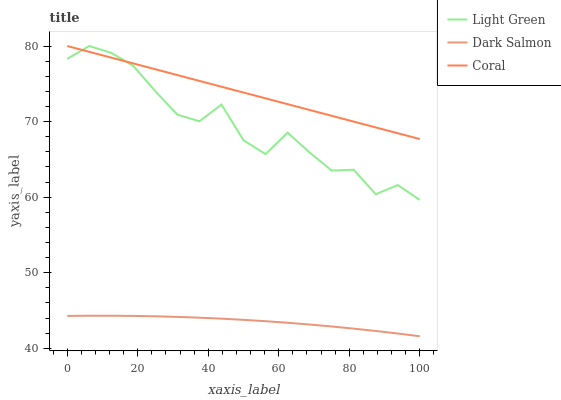Does Dark Salmon have the minimum area under the curve?
Answer yes or no. Yes. Does Coral have the maximum area under the curve?
Answer yes or no. Yes. Does Light Green have the minimum area under the curve?
Answer yes or no. No. Does Light Green have the maximum area under the curve?
Answer yes or no. No. Is Coral the smoothest?
Answer yes or no. Yes. Is Light Green the roughest?
Answer yes or no. Yes. Is Dark Salmon the smoothest?
Answer yes or no. No. Is Dark Salmon the roughest?
Answer yes or no. No. Does Dark Salmon have the lowest value?
Answer yes or no. Yes. Does Light Green have the lowest value?
Answer yes or no. No. Does Light Green have the highest value?
Answer yes or no. Yes. Does Dark Salmon have the highest value?
Answer yes or no. No. Is Dark Salmon less than Coral?
Answer yes or no. Yes. Is Coral greater than Dark Salmon?
Answer yes or no. Yes. Does Coral intersect Light Green?
Answer yes or no. Yes. Is Coral less than Light Green?
Answer yes or no. No. Is Coral greater than Light Green?
Answer yes or no. No. Does Dark Salmon intersect Coral?
Answer yes or no. No. 